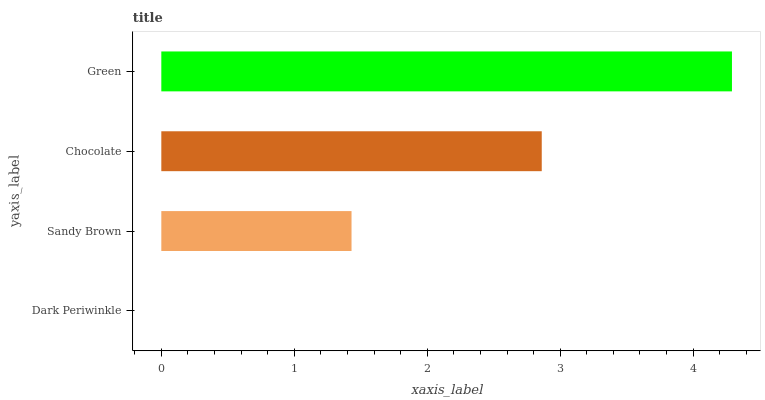Is Dark Periwinkle the minimum?
Answer yes or no. Yes. Is Green the maximum?
Answer yes or no. Yes. Is Sandy Brown the minimum?
Answer yes or no. No. Is Sandy Brown the maximum?
Answer yes or no. No. Is Sandy Brown greater than Dark Periwinkle?
Answer yes or no. Yes. Is Dark Periwinkle less than Sandy Brown?
Answer yes or no. Yes. Is Dark Periwinkle greater than Sandy Brown?
Answer yes or no. No. Is Sandy Brown less than Dark Periwinkle?
Answer yes or no. No. Is Chocolate the high median?
Answer yes or no. Yes. Is Sandy Brown the low median?
Answer yes or no. Yes. Is Green the high median?
Answer yes or no. No. Is Green the low median?
Answer yes or no. No. 